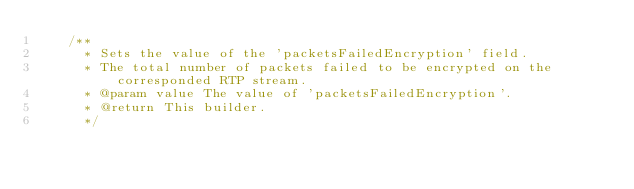<code> <loc_0><loc_0><loc_500><loc_500><_Java_>    /**
      * Sets the value of the 'packetsFailedEncryption' field.
      * The total number of packets failed to be encrypted on the corresponded RTP stream.
      * @param value The value of 'packetsFailedEncryption'.
      * @return This builder.
      */</code> 